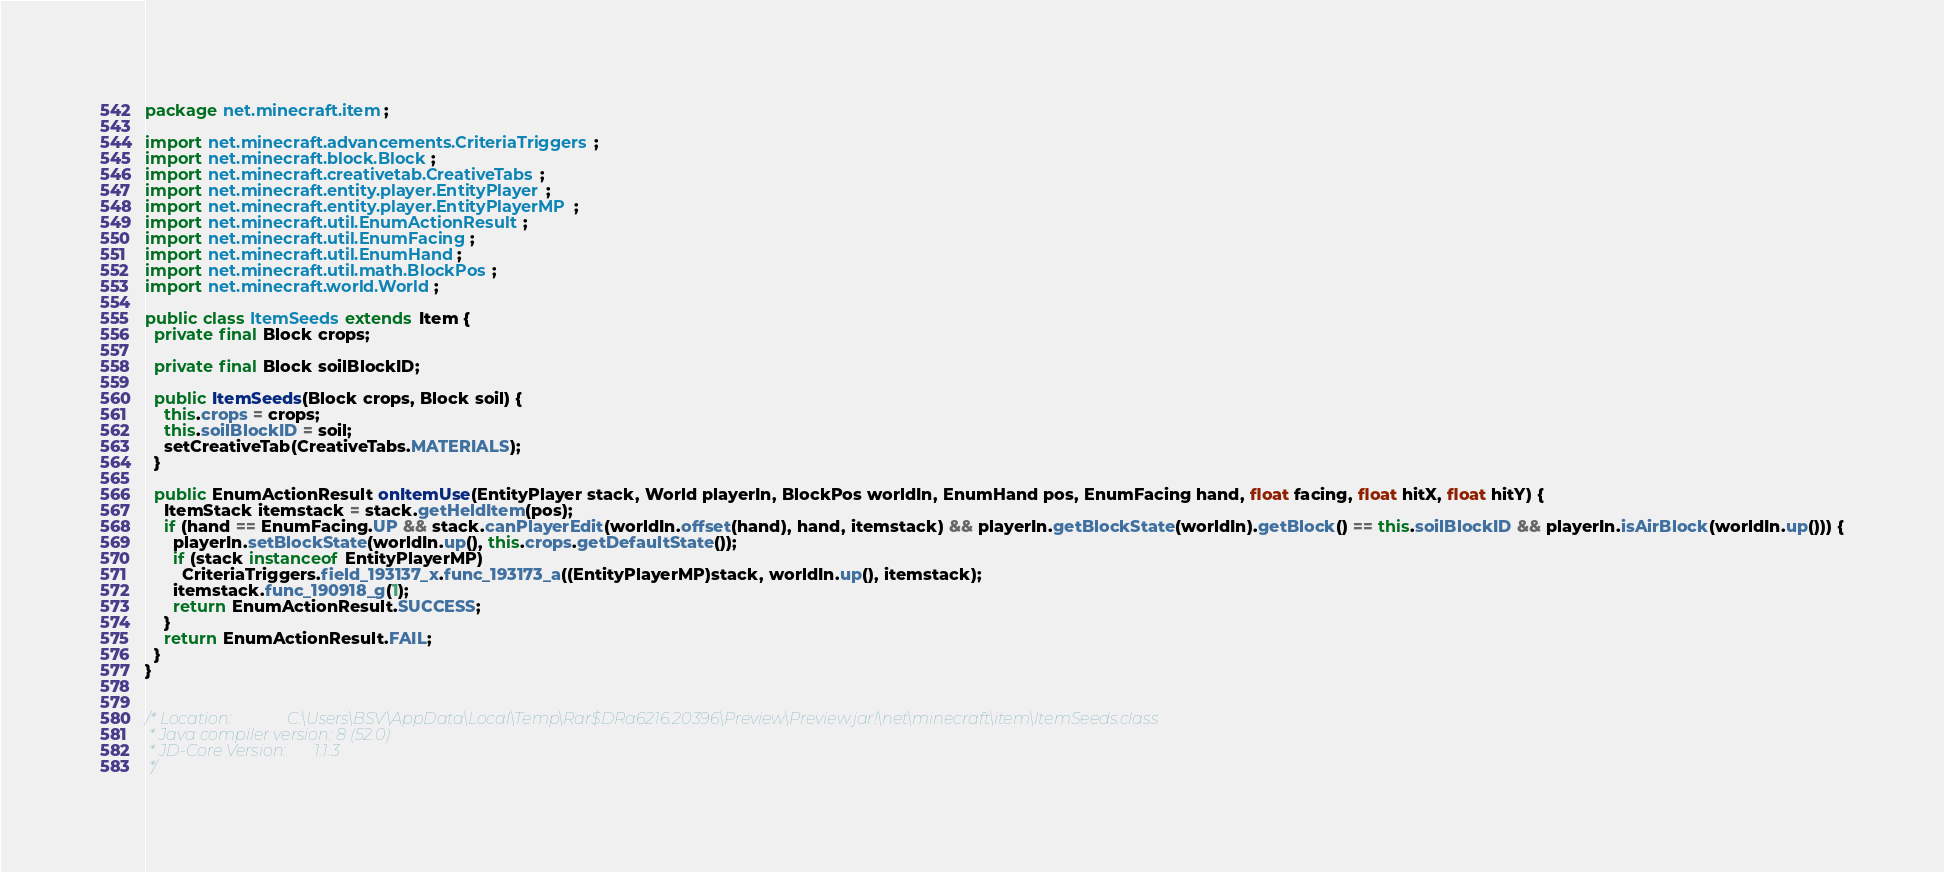<code> <loc_0><loc_0><loc_500><loc_500><_Java_>package net.minecraft.item;

import net.minecraft.advancements.CriteriaTriggers;
import net.minecraft.block.Block;
import net.minecraft.creativetab.CreativeTabs;
import net.minecraft.entity.player.EntityPlayer;
import net.minecraft.entity.player.EntityPlayerMP;
import net.minecraft.util.EnumActionResult;
import net.minecraft.util.EnumFacing;
import net.minecraft.util.EnumHand;
import net.minecraft.util.math.BlockPos;
import net.minecraft.world.World;

public class ItemSeeds extends Item {
  private final Block crops;
  
  private final Block soilBlockID;
  
  public ItemSeeds(Block crops, Block soil) {
    this.crops = crops;
    this.soilBlockID = soil;
    setCreativeTab(CreativeTabs.MATERIALS);
  }
  
  public EnumActionResult onItemUse(EntityPlayer stack, World playerIn, BlockPos worldIn, EnumHand pos, EnumFacing hand, float facing, float hitX, float hitY) {
    ItemStack itemstack = stack.getHeldItem(pos);
    if (hand == EnumFacing.UP && stack.canPlayerEdit(worldIn.offset(hand), hand, itemstack) && playerIn.getBlockState(worldIn).getBlock() == this.soilBlockID && playerIn.isAirBlock(worldIn.up())) {
      playerIn.setBlockState(worldIn.up(), this.crops.getDefaultState());
      if (stack instanceof EntityPlayerMP)
        CriteriaTriggers.field_193137_x.func_193173_a((EntityPlayerMP)stack, worldIn.up(), itemstack); 
      itemstack.func_190918_g(1);
      return EnumActionResult.SUCCESS;
    } 
    return EnumActionResult.FAIL;
  }
}


/* Location:              C:\Users\BSV\AppData\Local\Temp\Rar$DRa6216.20396\Preview\Preview.jar!\net\minecraft\item\ItemSeeds.class
 * Java compiler version: 8 (52.0)
 * JD-Core Version:       1.1.3
 */</code> 